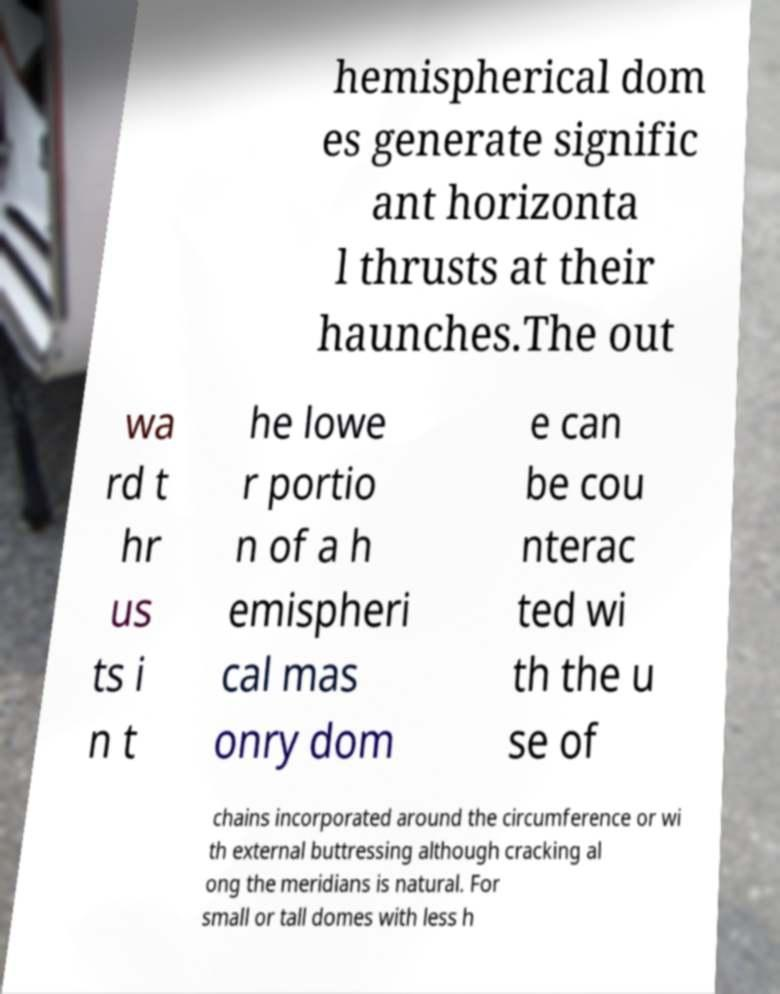What messages or text are displayed in this image? I need them in a readable, typed format. hemispherical dom es generate signific ant horizonta l thrusts at their haunches.The out wa rd t hr us ts i n t he lowe r portio n of a h emispheri cal mas onry dom e can be cou nterac ted wi th the u se of chains incorporated around the circumference or wi th external buttressing although cracking al ong the meridians is natural. For small or tall domes with less h 